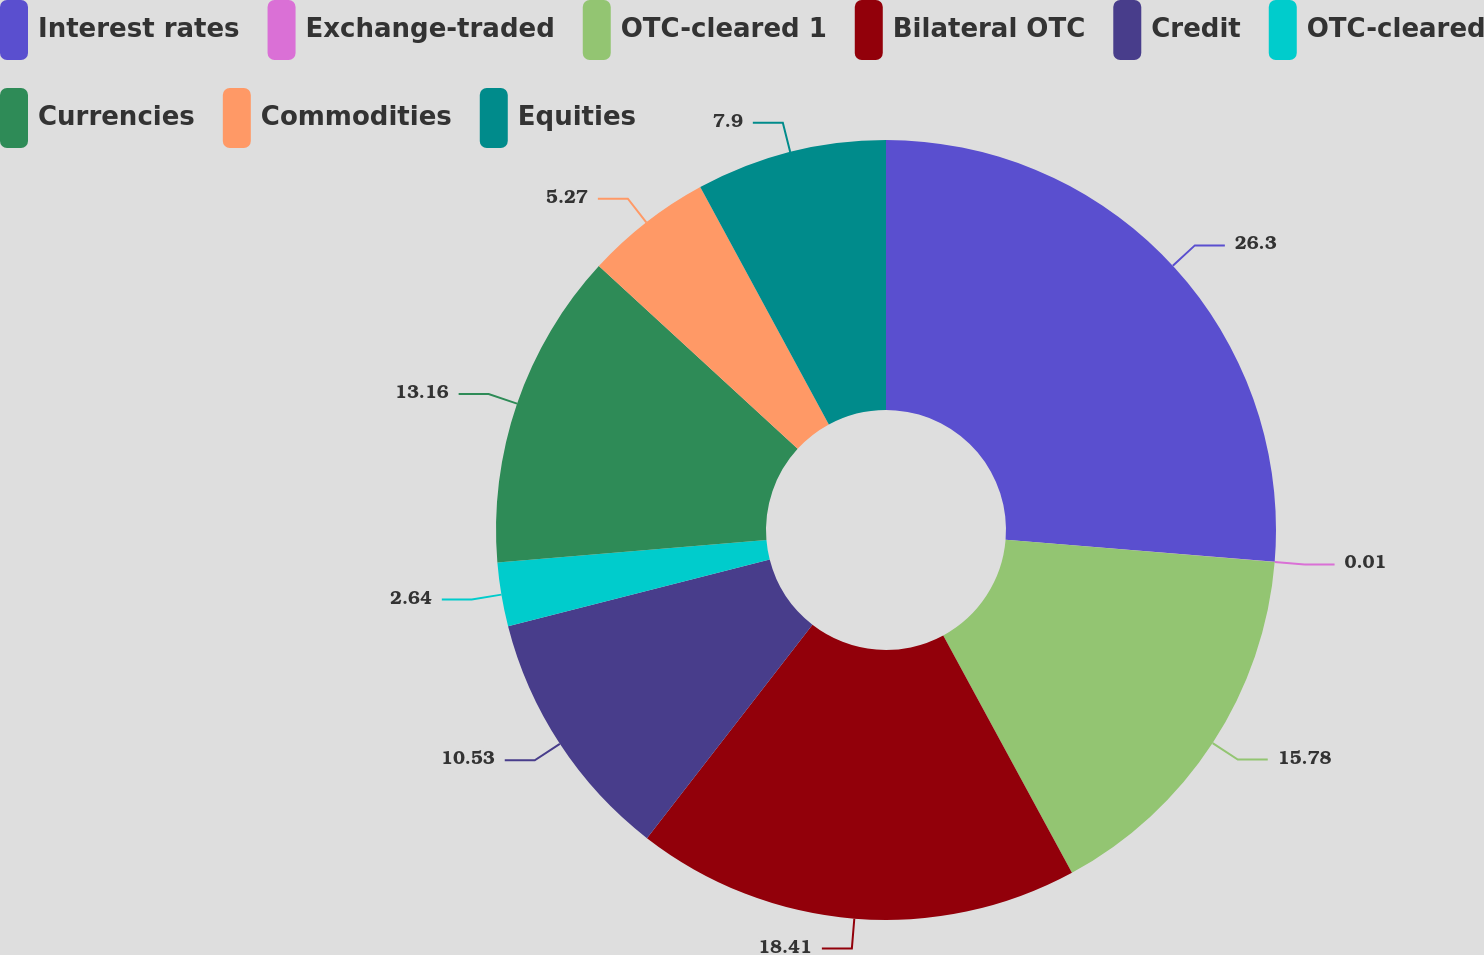<chart> <loc_0><loc_0><loc_500><loc_500><pie_chart><fcel>Interest rates<fcel>Exchange-traded<fcel>OTC-cleared 1<fcel>Bilateral OTC<fcel>Credit<fcel>OTC-cleared<fcel>Currencies<fcel>Commodities<fcel>Equities<nl><fcel>26.3%<fcel>0.01%<fcel>15.78%<fcel>18.41%<fcel>10.53%<fcel>2.64%<fcel>13.16%<fcel>5.27%<fcel>7.9%<nl></chart> 